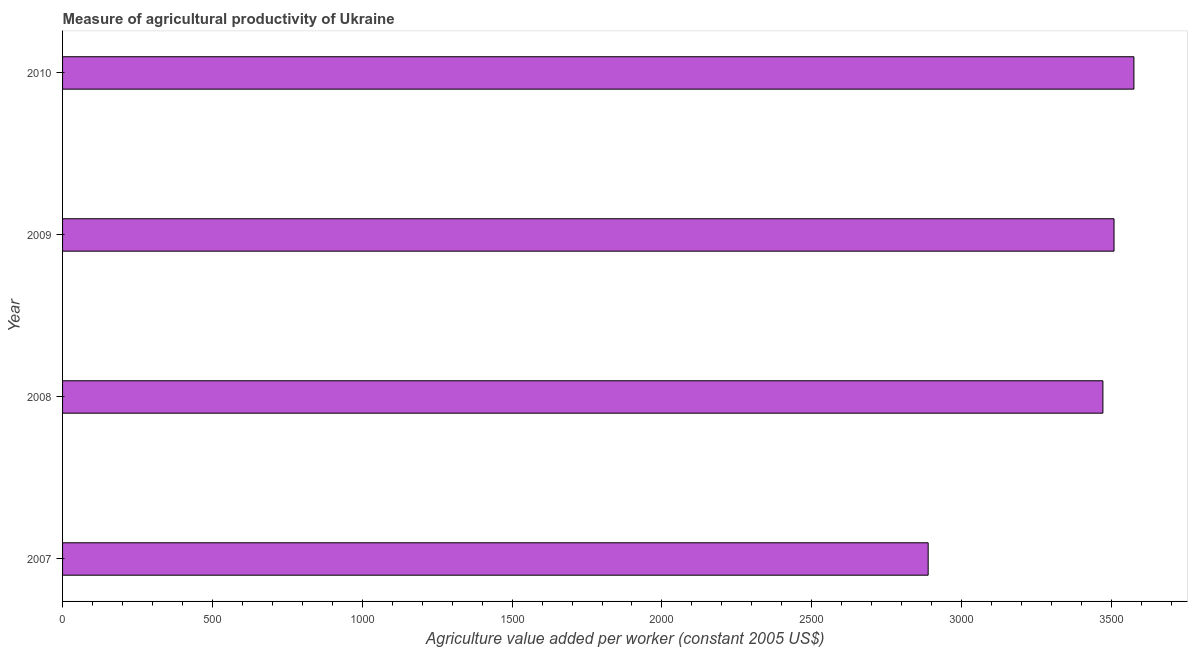Does the graph contain any zero values?
Make the answer very short. No. What is the title of the graph?
Give a very brief answer. Measure of agricultural productivity of Ukraine. What is the label or title of the X-axis?
Make the answer very short. Agriculture value added per worker (constant 2005 US$). What is the agriculture value added per worker in 2010?
Give a very brief answer. 3574.83. Across all years, what is the maximum agriculture value added per worker?
Ensure brevity in your answer.  3574.83. Across all years, what is the minimum agriculture value added per worker?
Provide a short and direct response. 2888.27. In which year was the agriculture value added per worker maximum?
Provide a short and direct response. 2010. What is the sum of the agriculture value added per worker?
Make the answer very short. 1.34e+04. What is the difference between the agriculture value added per worker in 2009 and 2010?
Ensure brevity in your answer.  -66.37. What is the average agriculture value added per worker per year?
Make the answer very short. 3360.72. What is the median agriculture value added per worker?
Give a very brief answer. 3489.89. Do a majority of the years between 2008 and 2009 (inclusive) have agriculture value added per worker greater than 400 US$?
Provide a succinct answer. Yes. What is the ratio of the agriculture value added per worker in 2009 to that in 2010?
Provide a short and direct response. 0.98. Is the agriculture value added per worker in 2007 less than that in 2010?
Your response must be concise. Yes. Is the difference between the agriculture value added per worker in 2008 and 2009 greater than the difference between any two years?
Your response must be concise. No. What is the difference between the highest and the second highest agriculture value added per worker?
Provide a succinct answer. 66.37. What is the difference between the highest and the lowest agriculture value added per worker?
Keep it short and to the point. 686.57. In how many years, is the agriculture value added per worker greater than the average agriculture value added per worker taken over all years?
Make the answer very short. 3. Are all the bars in the graph horizontal?
Provide a short and direct response. Yes. How many years are there in the graph?
Ensure brevity in your answer.  4. Are the values on the major ticks of X-axis written in scientific E-notation?
Keep it short and to the point. No. What is the Agriculture value added per worker (constant 2005 US$) of 2007?
Provide a short and direct response. 2888.27. What is the Agriculture value added per worker (constant 2005 US$) in 2008?
Your answer should be very brief. 3471.32. What is the Agriculture value added per worker (constant 2005 US$) of 2009?
Make the answer very short. 3508.46. What is the Agriculture value added per worker (constant 2005 US$) in 2010?
Provide a short and direct response. 3574.83. What is the difference between the Agriculture value added per worker (constant 2005 US$) in 2007 and 2008?
Your answer should be very brief. -583.05. What is the difference between the Agriculture value added per worker (constant 2005 US$) in 2007 and 2009?
Offer a terse response. -620.19. What is the difference between the Agriculture value added per worker (constant 2005 US$) in 2007 and 2010?
Your answer should be compact. -686.57. What is the difference between the Agriculture value added per worker (constant 2005 US$) in 2008 and 2009?
Offer a terse response. -37.14. What is the difference between the Agriculture value added per worker (constant 2005 US$) in 2008 and 2010?
Provide a succinct answer. -103.51. What is the difference between the Agriculture value added per worker (constant 2005 US$) in 2009 and 2010?
Give a very brief answer. -66.37. What is the ratio of the Agriculture value added per worker (constant 2005 US$) in 2007 to that in 2008?
Ensure brevity in your answer.  0.83. What is the ratio of the Agriculture value added per worker (constant 2005 US$) in 2007 to that in 2009?
Give a very brief answer. 0.82. What is the ratio of the Agriculture value added per worker (constant 2005 US$) in 2007 to that in 2010?
Give a very brief answer. 0.81. What is the ratio of the Agriculture value added per worker (constant 2005 US$) in 2008 to that in 2010?
Provide a succinct answer. 0.97. 